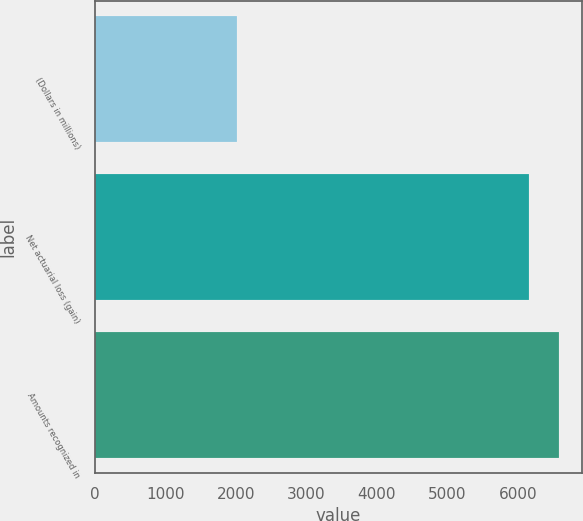<chart> <loc_0><loc_0><loc_500><loc_500><bar_chart><fcel>(Dollars in millions)<fcel>Net actuarial loss (gain)<fcel>Amounts recognized in<nl><fcel>2012<fcel>6164<fcel>6579.2<nl></chart> 